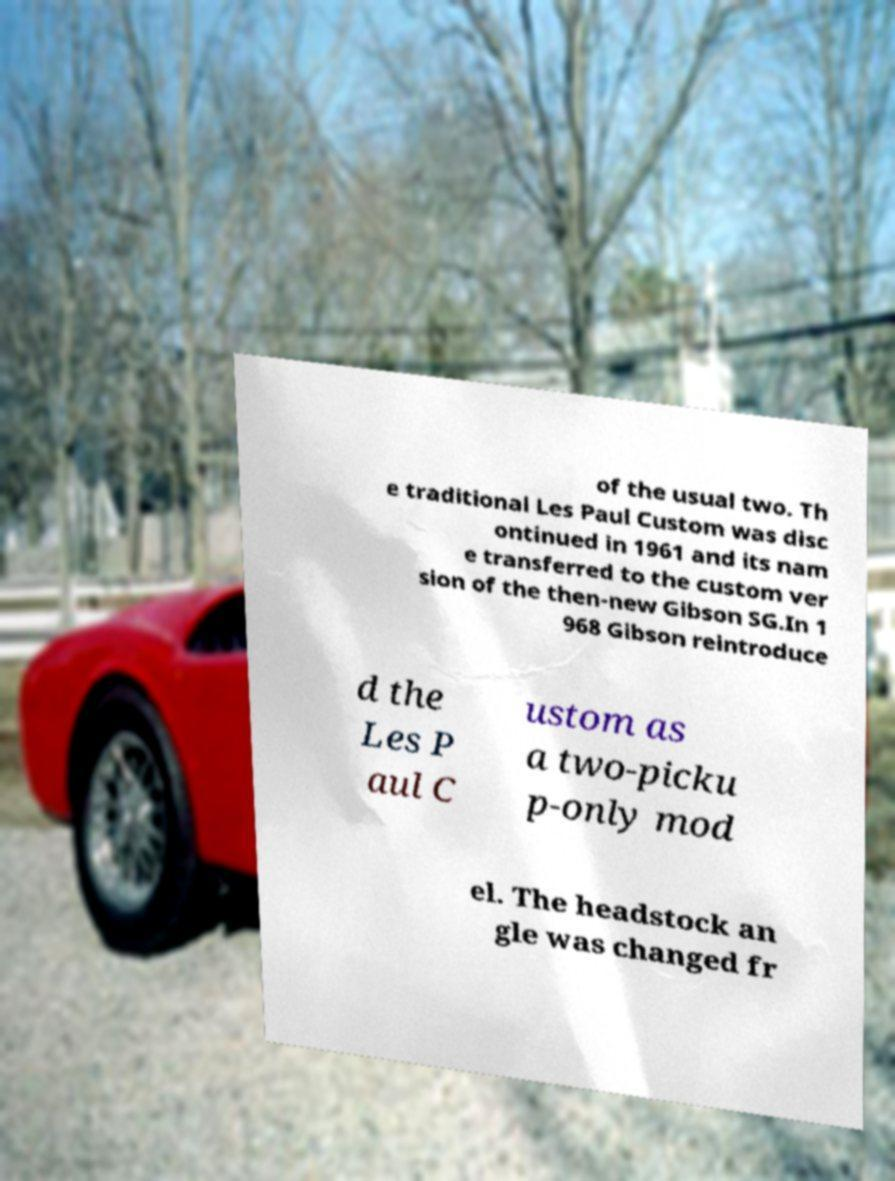There's text embedded in this image that I need extracted. Can you transcribe it verbatim? of the usual two. Th e traditional Les Paul Custom was disc ontinued in 1961 and its nam e transferred to the custom ver sion of the then-new Gibson SG.In 1 968 Gibson reintroduce d the Les P aul C ustom as a two-picku p-only mod el. The headstock an gle was changed fr 